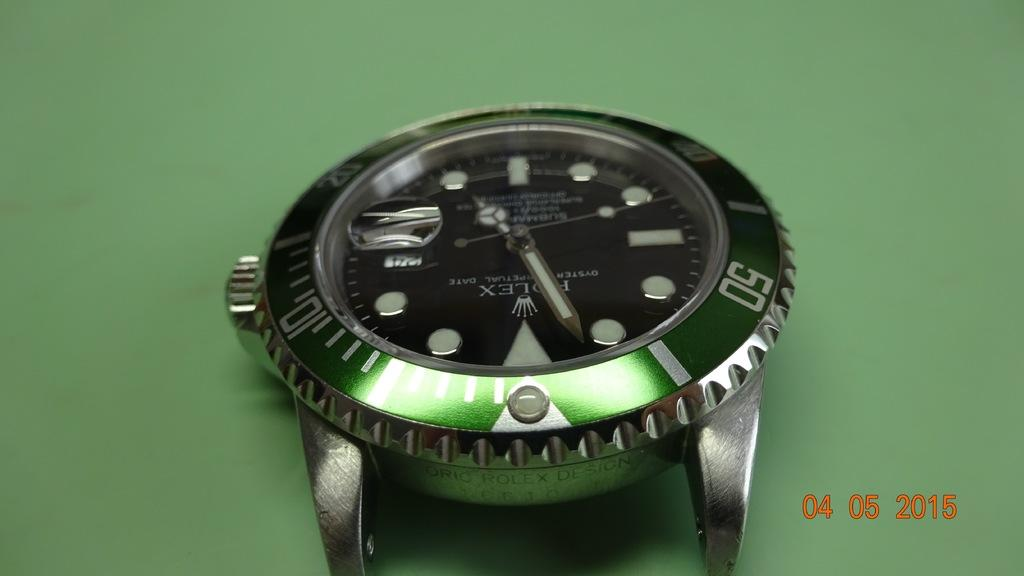<image>
Write a terse but informative summary of the picture. A watch lies on its back with no strap and tells the time as almost 5 o'clock. 